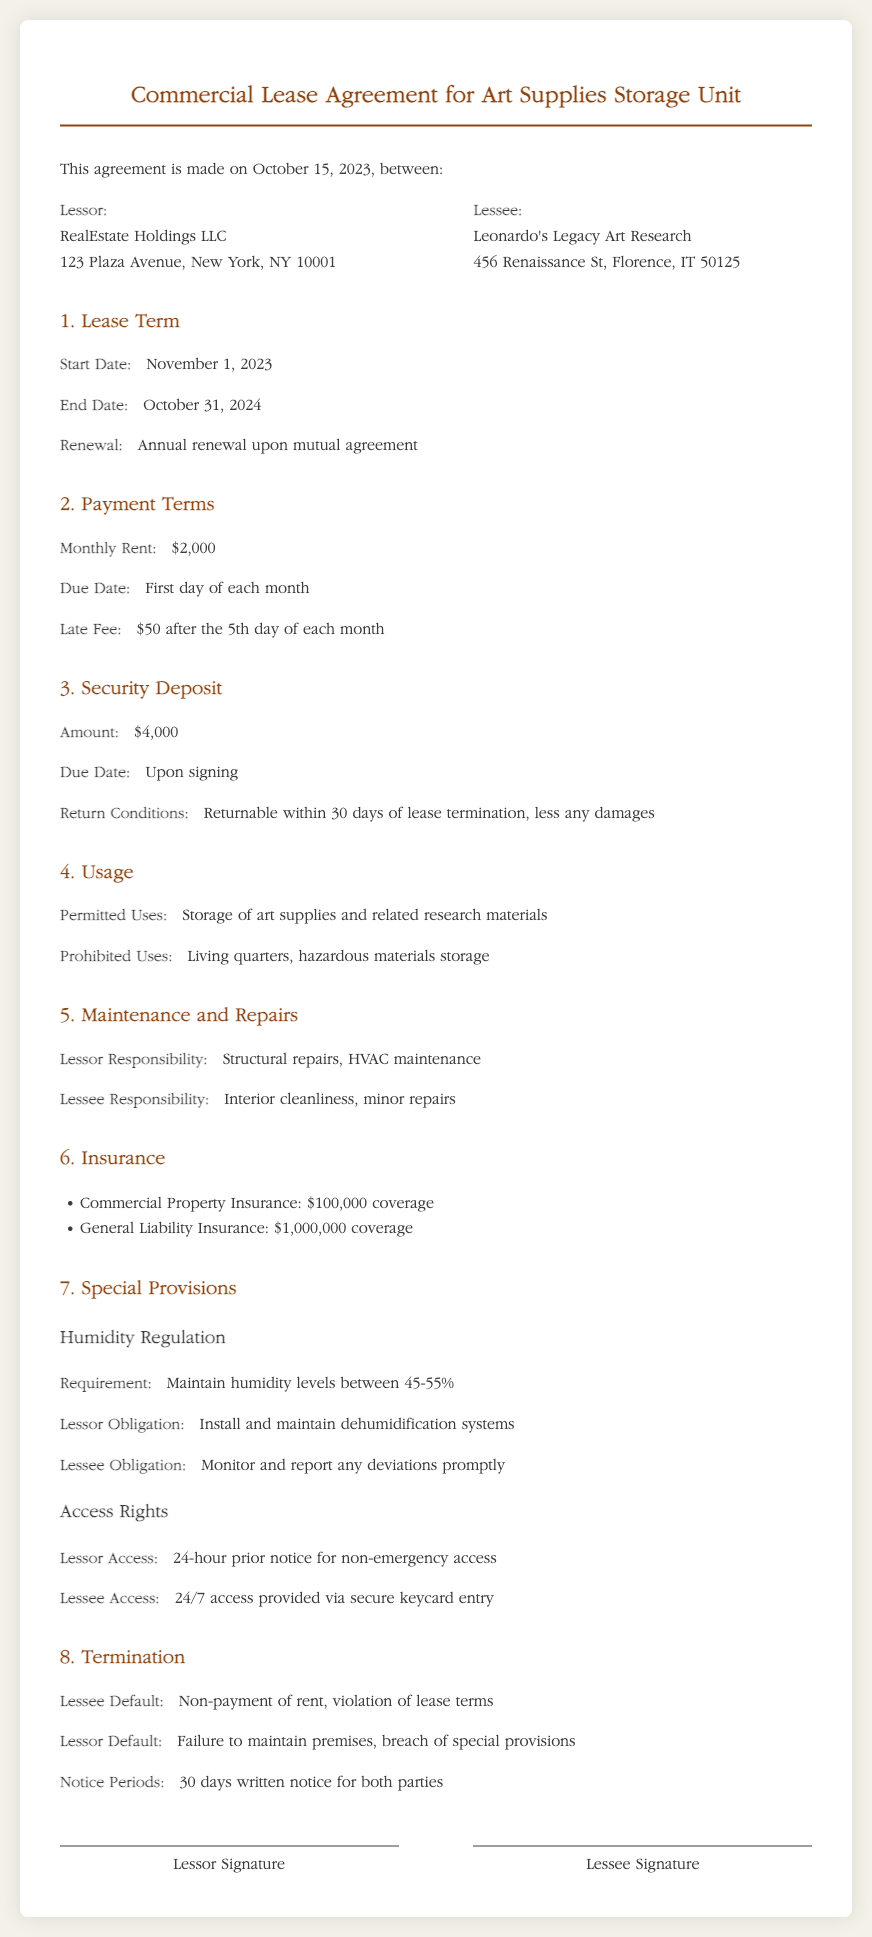What is the start date of the lease? The start date for the lease is mentioned in the Lease Term section.
Answer: November 1, 2023 What is the monthly rent amount? The monthly rent amount is detailed in the Payment Terms section of the document.
Answer: $2,000 What is the security deposit amount? The security deposit amount is specified in the Security Deposit section of the document.
Answer: $4,000 What humidity level must be maintained? The required humidity level is stated in the Humidity Regulation section.
Answer: 45-55% How much notice is required for lessor access? The notice requirement for lessor access is stated under the Access Rights section.
Answer: 24-hour prior notice What are the lessee's responsibilities regarding maintenance? The lessee's maintenance responsibilities are outlined in the Maintenance and Repairs section.
Answer: Interior cleanliness, minor repairs What insurance coverage is required for general liability? The insurance coverage for general liability is listed in the Insurance section.
Answer: $1,000,000 What happens if the lessee defaults? The consequences for lessee default are mentioned in the Termination section of the document.
Answer: Non-payment of rent, violation of lease terms What is the renewal condition of the lease? The renewal condition is specified in the Lease Term section of the agreement.
Answer: Annual renewal upon mutual agreement 